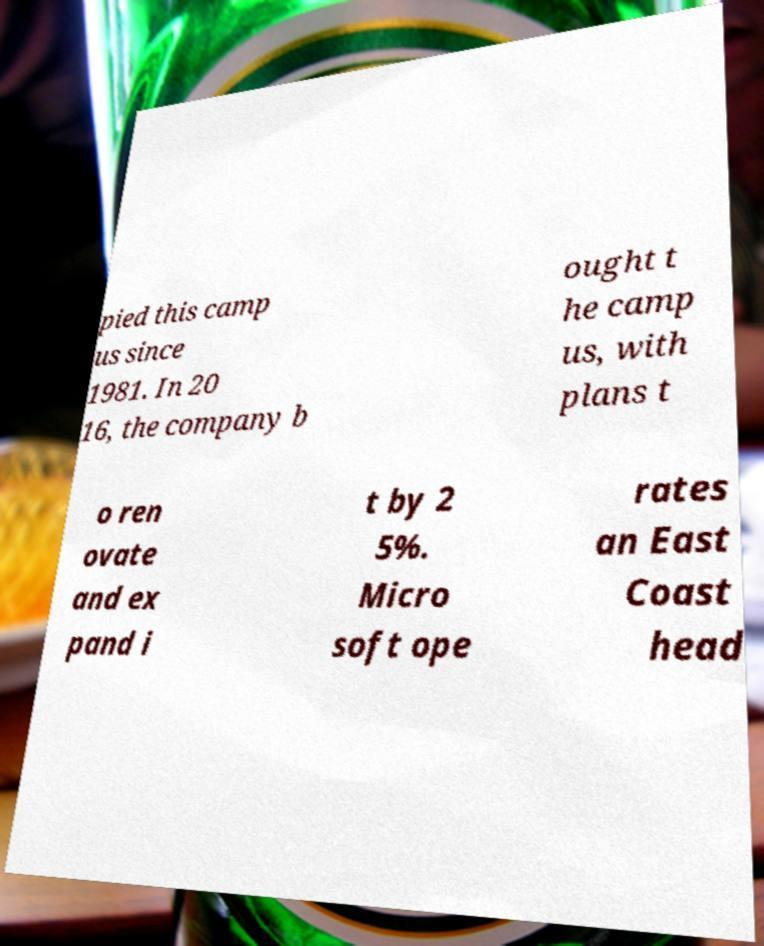There's text embedded in this image that I need extracted. Can you transcribe it verbatim? pied this camp us since 1981. In 20 16, the company b ought t he camp us, with plans t o ren ovate and ex pand i t by 2 5%. Micro soft ope rates an East Coast head 